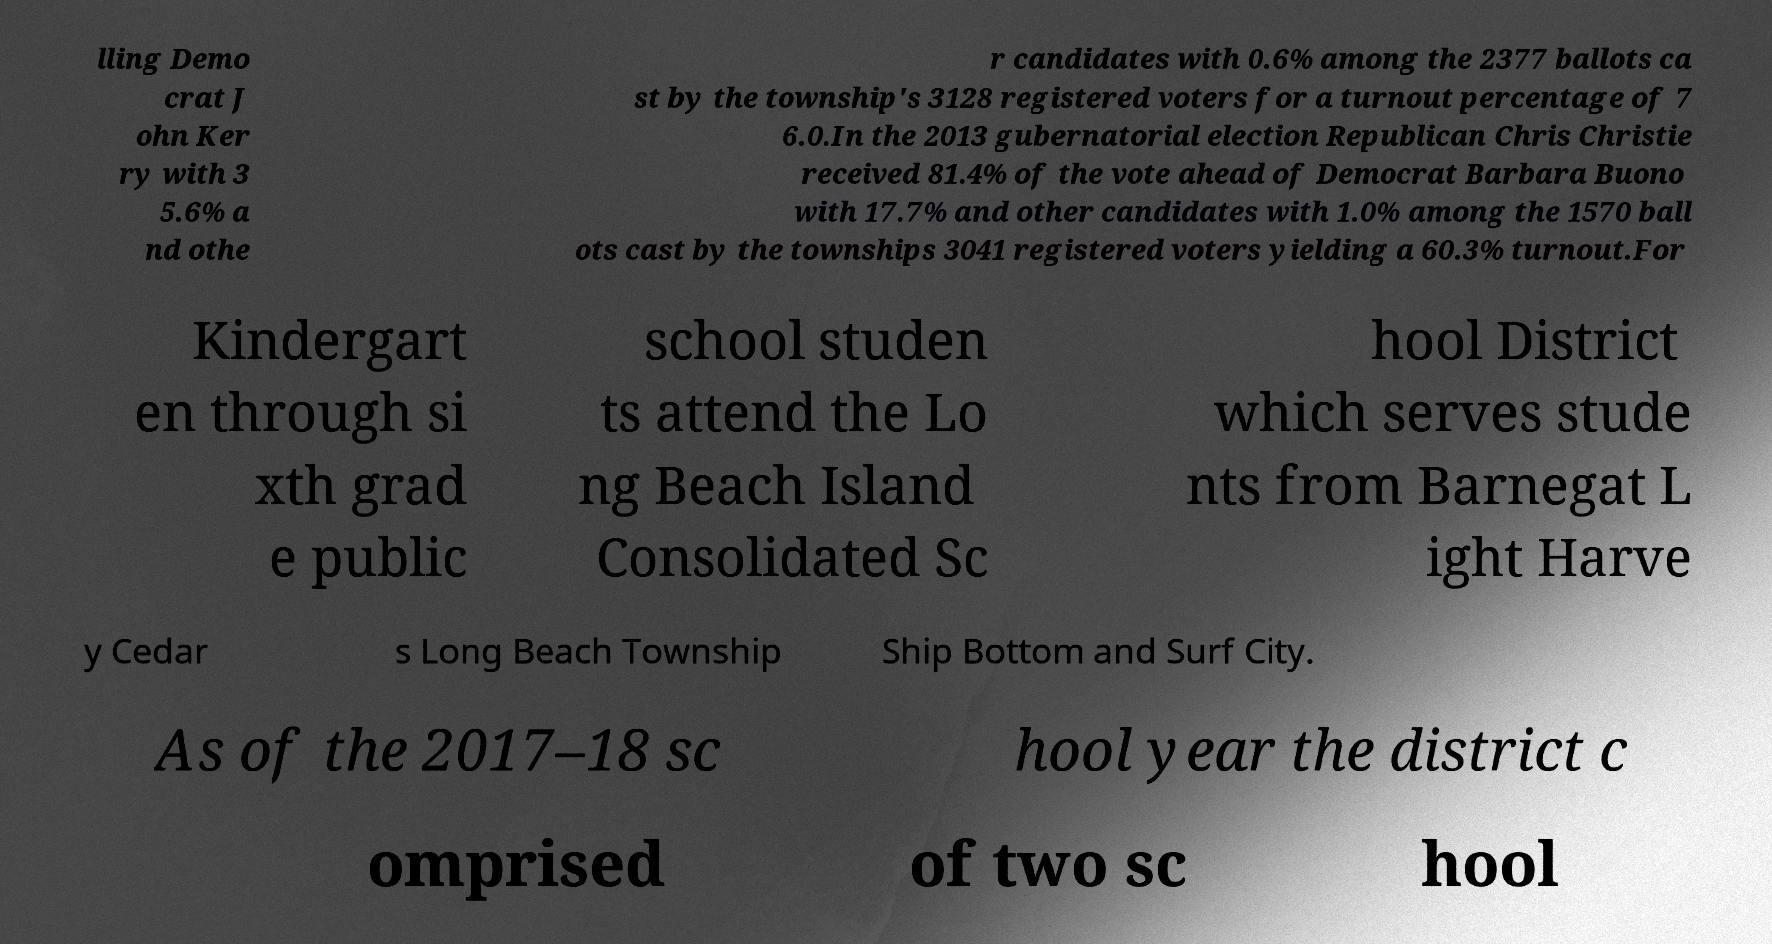For documentation purposes, I need the text within this image transcribed. Could you provide that? lling Demo crat J ohn Ker ry with 3 5.6% a nd othe r candidates with 0.6% among the 2377 ballots ca st by the township's 3128 registered voters for a turnout percentage of 7 6.0.In the 2013 gubernatorial election Republican Chris Christie received 81.4% of the vote ahead of Democrat Barbara Buono with 17.7% and other candidates with 1.0% among the 1570 ball ots cast by the townships 3041 registered voters yielding a 60.3% turnout.For Kindergart en through si xth grad e public school studen ts attend the Lo ng Beach Island Consolidated Sc hool District which serves stude nts from Barnegat L ight Harve y Cedar s Long Beach Township Ship Bottom and Surf City. As of the 2017–18 sc hool year the district c omprised of two sc hool 